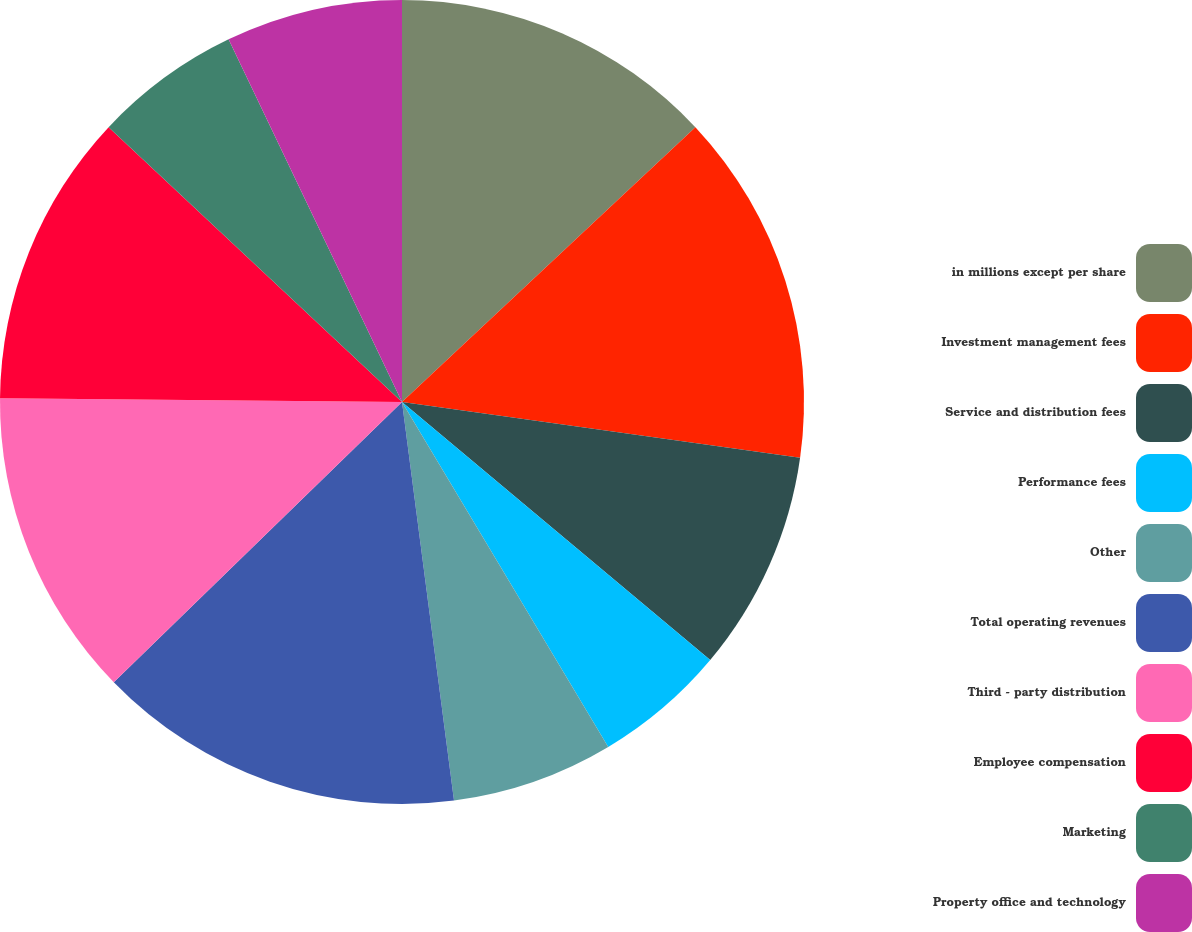Convert chart to OTSL. <chart><loc_0><loc_0><loc_500><loc_500><pie_chart><fcel>in millions except per share<fcel>Investment management fees<fcel>Service and distribution fees<fcel>Performance fees<fcel>Other<fcel>Total operating revenues<fcel>Third - party distribution<fcel>Employee compensation<fcel>Marketing<fcel>Property office and technology<nl><fcel>13.02%<fcel>14.2%<fcel>8.88%<fcel>5.33%<fcel>6.51%<fcel>14.79%<fcel>12.43%<fcel>11.83%<fcel>5.92%<fcel>7.1%<nl></chart> 